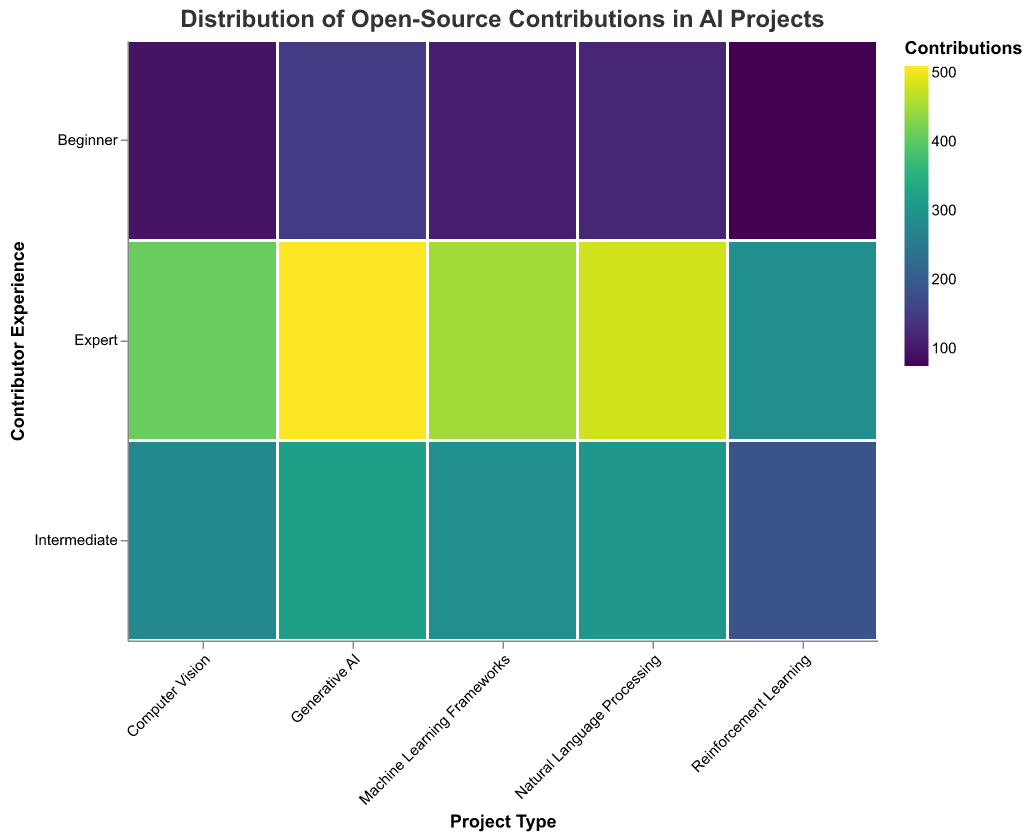What is the title of the figure? The title of the figure is shown at the top in a larger font size compared to the other text. It helps to understand the main subject of the visualization.
Answer: Distribution of Open-Source Contributions in AI Projects Which project type shows the highest number of contributions from experts? By looking at the color intensity in the rectangle corresponding to experts in each project type, the darkest (deepest) color indicates the highest number. This is found in the rectangle for Generative AI.
Answer: Generative AI How many contributions are there from intermediate contributors in the Generative AI projects? Locate the "Generative AI" column, and within it, check the rectangle corresponding to "Intermediate." The color legend indicates the value of contributions.
Answer: 320 Compare the contributions from beginner contributors in Computer Vision and Natural Language Processing projects. Which is higher? Compare the rectangles for "Beginner" in both project types by looking at the color intensity. Natural Language Processing has a higher value.
Answer: Natural Language Processing What is the total number of contributions from expert contributors across all project types? Sum the contributions for expert contributors in each project type: 480 (NLP) + 410 (CV) + 290 (RL) + 510 (Gen AI) + 450 (ML Frameworks) = 2140
Answer: 2140 Which contributor experience level has the least number of contributions in Reinforcement Learning? Inspect the three rectangles within the "Reinforcement Learning" column; the rectangle with the lightest color has the lowest number, which corresponds to "Beginner."
Answer: Beginner How do the contributions from intermediate contributors in Machine Learning Frameworks compare to those in Computer Vision? Compare the rectangles for "Intermediate" in both columns. Machine Learning Frameworks has 290 contributions whereas Computer Vision has 280.
Answer: Machine Learning Frameworks What is the difference in contributions between beginner contributors in Generative AI and Reinforcement Learning? Find the beginner contribution values for these project types: 150 (Generative AI) - 75 (Reinforcement Learning) = 75
Answer: 75 Which project type has the second highest total contributions from all experience levels combined? Sum the contributions for all experience levels within each project type and compare. Calculating each: 
    NLP: 120+305+480=905 CV: 95+280+410=785 RL: 75+185+290=550 
    Gen AI: 150+320+510=980 ML Frameworks: 110+290+450=850
    Generative AI has the highest (980), and NLP has the second highest (905).
Answer: Natural Language Processing What is the average number of contributions for intermediate contributors across all project types? Sum the intermediate contribution numbers: 305 + 280 + 185 + 320 + 290 = 1380. Then, determine the average: 1380 / 5 = 276
Answer: 276 